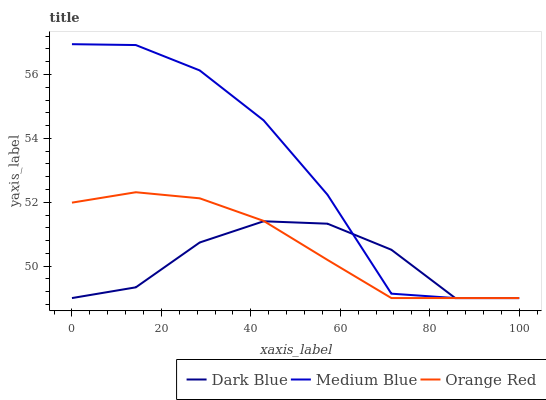Does Dark Blue have the minimum area under the curve?
Answer yes or no. Yes. Does Medium Blue have the maximum area under the curve?
Answer yes or no. Yes. Does Orange Red have the minimum area under the curve?
Answer yes or no. No. Does Orange Red have the maximum area under the curve?
Answer yes or no. No. Is Orange Red the smoothest?
Answer yes or no. Yes. Is Medium Blue the roughest?
Answer yes or no. Yes. Is Medium Blue the smoothest?
Answer yes or no. No. Is Orange Red the roughest?
Answer yes or no. No. Does Dark Blue have the lowest value?
Answer yes or no. Yes. Does Medium Blue have the highest value?
Answer yes or no. Yes. Does Orange Red have the highest value?
Answer yes or no. No. Does Medium Blue intersect Dark Blue?
Answer yes or no. Yes. Is Medium Blue less than Dark Blue?
Answer yes or no. No. Is Medium Blue greater than Dark Blue?
Answer yes or no. No. 